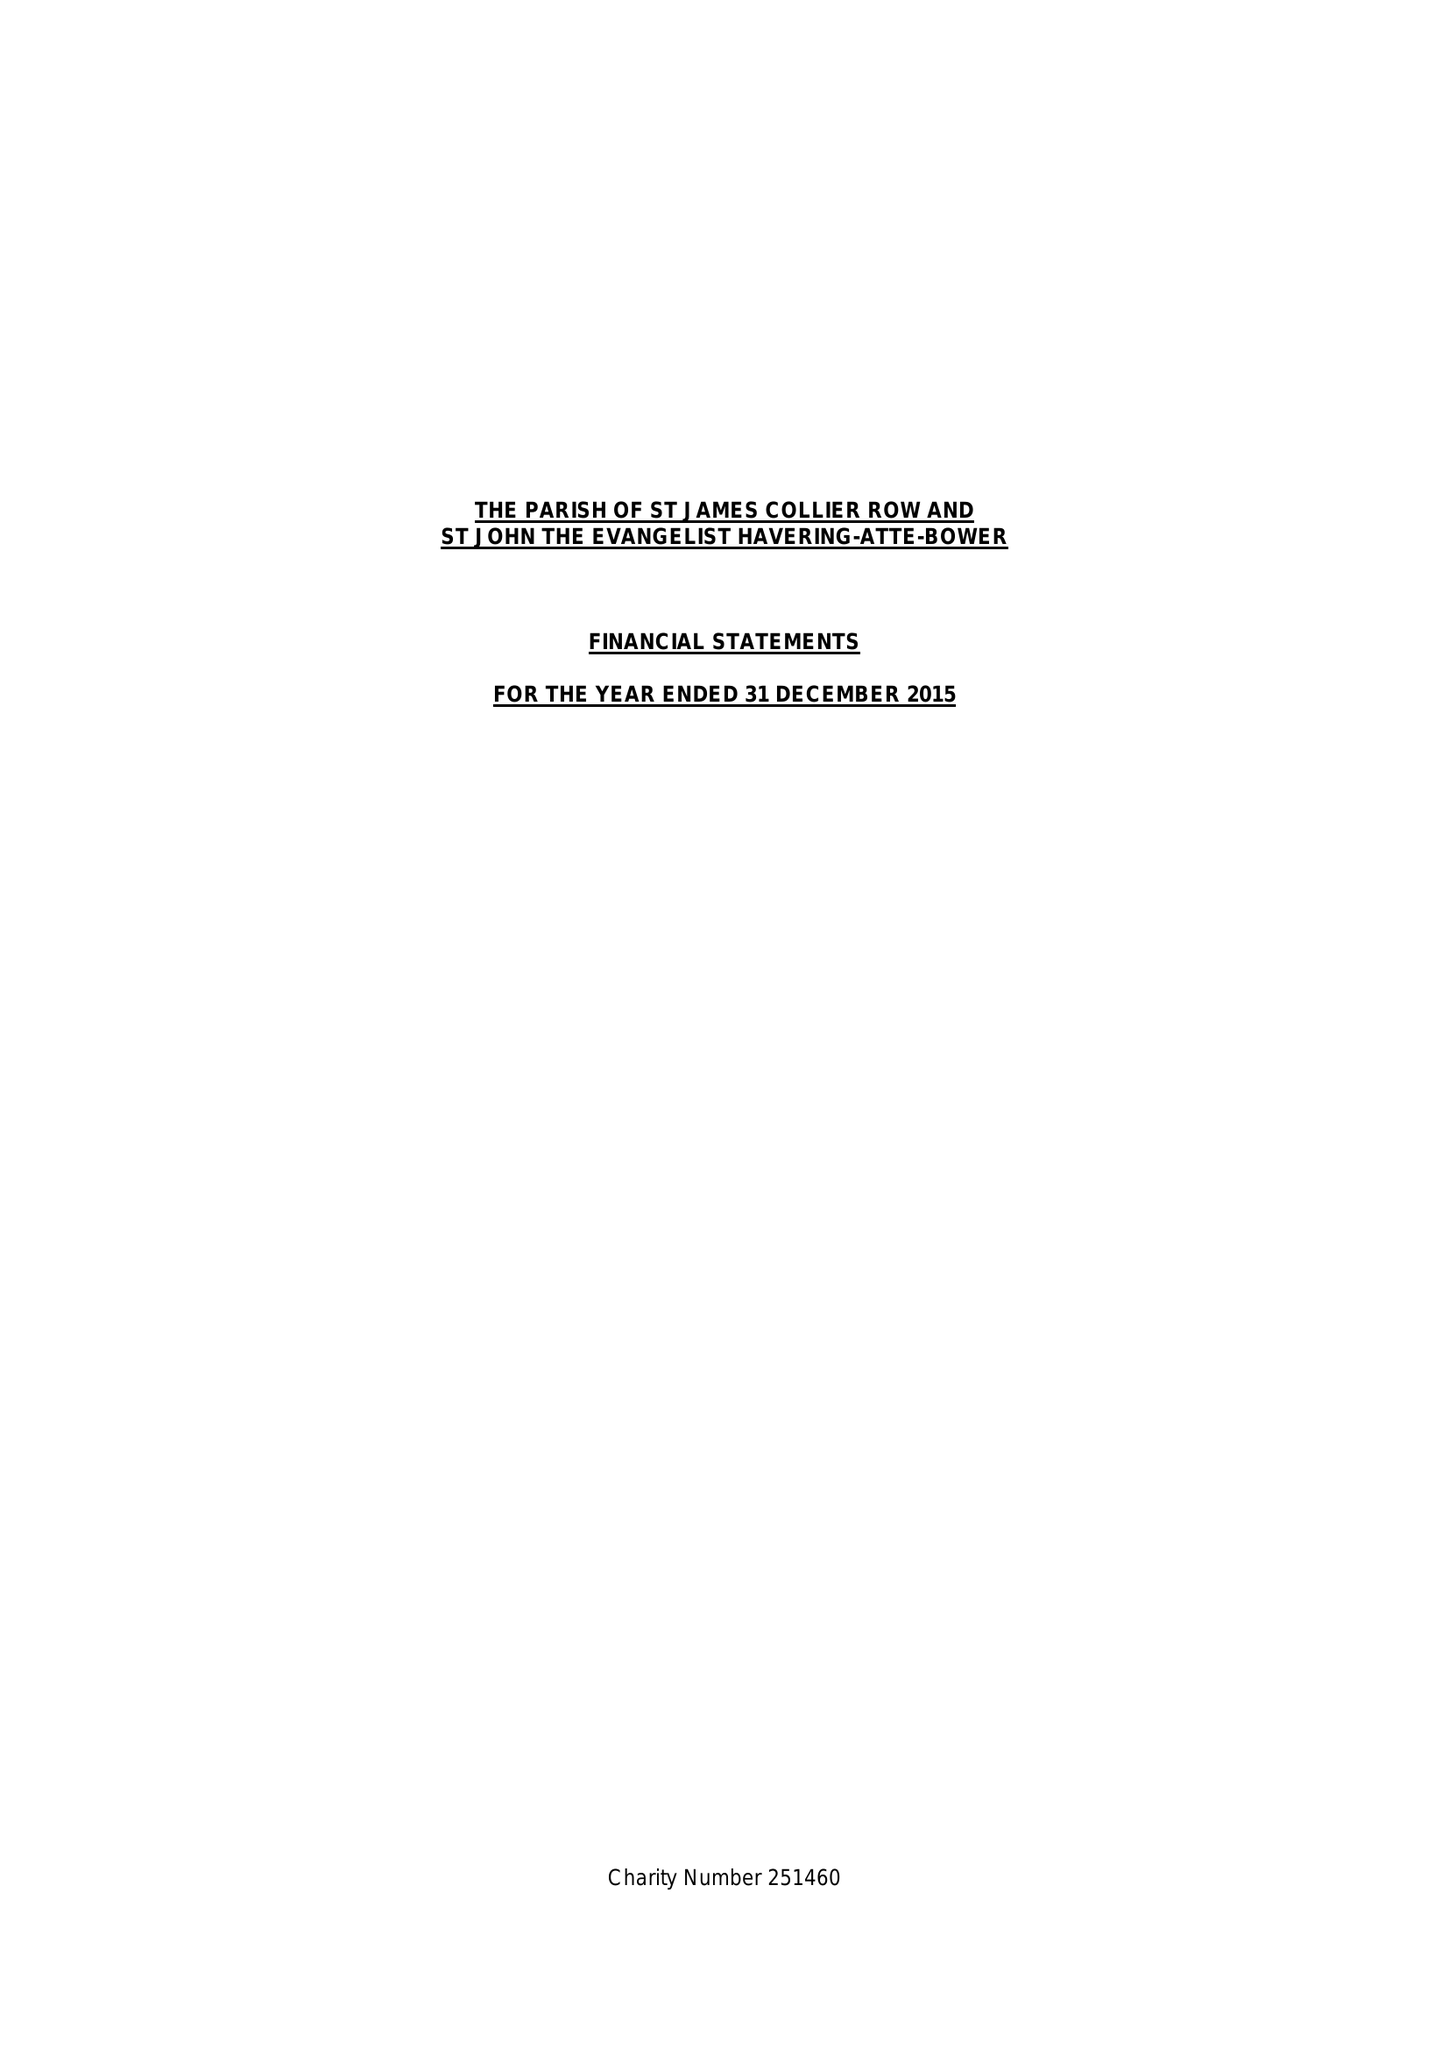What is the value for the address__post_town?
Answer the question using a single word or phrase. ROMFORD 